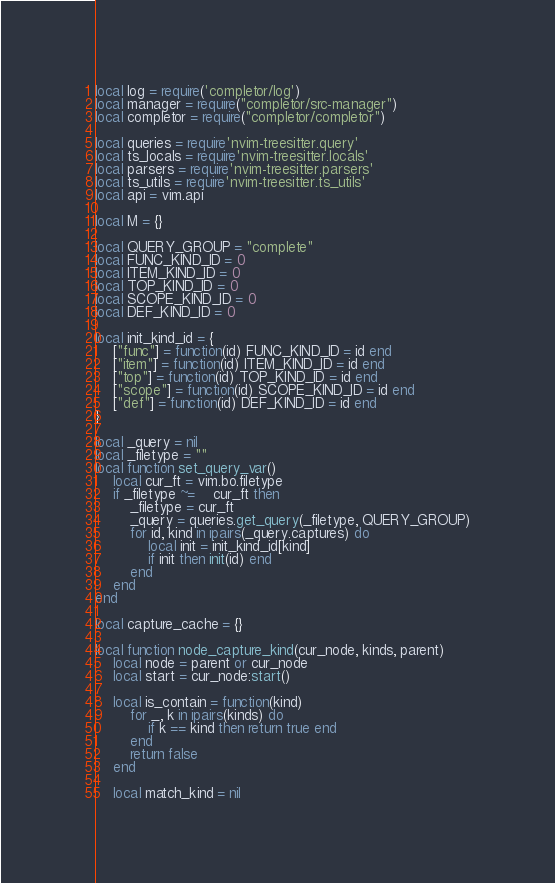Convert code to text. <code><loc_0><loc_0><loc_500><loc_500><_Lua_>local log = require('completor/log')
local manager = require("completor/src-manager")
local completor = require("completor/completor")

local queries = require'nvim-treesitter.query'
local ts_locals = require'nvim-treesitter.locals'
local parsers = require'nvim-treesitter.parsers'
local ts_utils = require'nvim-treesitter.ts_utils'
local api = vim.api

local M = {}

local QUERY_GROUP = "complete"
local FUNC_KIND_ID = 0
local ITEM_KIND_ID = 0
local TOP_KIND_ID = 0
local SCOPE_KIND_ID = 0
local DEF_KIND_ID = 0

local init_kind_id = {
	["func"] = function(id) FUNC_KIND_ID = id end
	["item"] = function(id) ITEM_KIND_ID = id end
	["top"] = function(id) TOP_KIND_ID = id end
	["scope"] = function(id) SCOPE_KIND_ID = id end
	["def"] = function(id) DEF_KIND_ID = id end
}

local _query = nil
local _filetype = ""
local function set_query_var()
	local cur_ft = vim.bo.filetype
	if _filetype ~=	cur_ft then
		_filetype = cur_ft
		_query = queries.get_query(_filetype, QUERY_GROUP)
		for id, kind in ipairs(_query.captures) do
			local init = init_kind_id[kind]
			if init then init(id) end
		end
	end
end

local capture_cache = {}

local function node_capture_kind(cur_node, kinds, parent)
	local node = parent or cur_node
	local start = cur_node:start()

	local is_contain = function(kind)
		for _, k in ipairs(kinds) do
			if k == kind then return true end
		end
		return false
	end

	local match_kind = nil</code> 